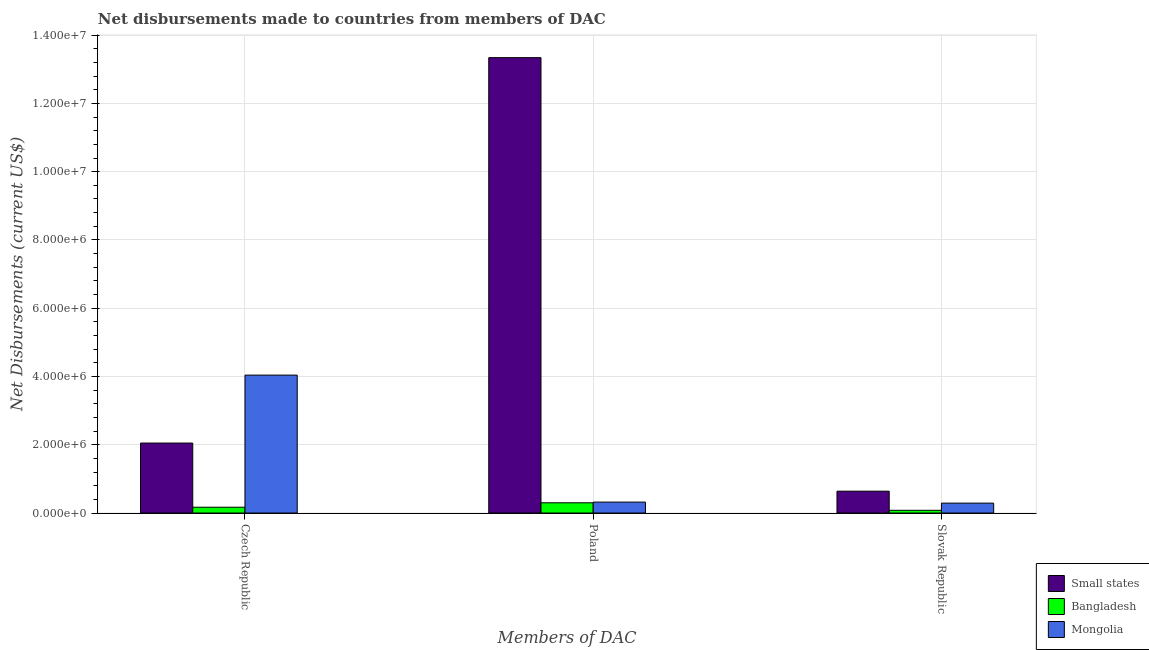How many different coloured bars are there?
Keep it short and to the point. 3. Are the number of bars on each tick of the X-axis equal?
Make the answer very short. Yes. How many bars are there on the 3rd tick from the left?
Your answer should be compact. 3. How many bars are there on the 1st tick from the right?
Provide a succinct answer. 3. What is the label of the 3rd group of bars from the left?
Provide a short and direct response. Slovak Republic. What is the net disbursements made by czech republic in Mongolia?
Make the answer very short. 4.04e+06. Across all countries, what is the maximum net disbursements made by poland?
Make the answer very short. 1.33e+07. Across all countries, what is the minimum net disbursements made by slovak republic?
Make the answer very short. 8.00e+04. In which country was the net disbursements made by slovak republic maximum?
Make the answer very short. Small states. In which country was the net disbursements made by poland minimum?
Ensure brevity in your answer.  Bangladesh. What is the total net disbursements made by slovak republic in the graph?
Your response must be concise. 1.01e+06. What is the difference between the net disbursements made by slovak republic in Bangladesh and that in Mongolia?
Ensure brevity in your answer.  -2.10e+05. What is the difference between the net disbursements made by slovak republic in Bangladesh and the net disbursements made by czech republic in Mongolia?
Make the answer very short. -3.96e+06. What is the average net disbursements made by slovak republic per country?
Your response must be concise. 3.37e+05. What is the difference between the net disbursements made by poland and net disbursements made by slovak republic in Bangladesh?
Make the answer very short. 2.20e+05. In how many countries, is the net disbursements made by slovak republic greater than 3200000 US$?
Keep it short and to the point. 0. What is the ratio of the net disbursements made by czech republic in Small states to that in Mongolia?
Provide a short and direct response. 0.51. Is the net disbursements made by czech republic in Small states less than that in Mongolia?
Offer a terse response. Yes. What is the difference between the highest and the second highest net disbursements made by czech republic?
Your answer should be compact. 1.99e+06. What is the difference between the highest and the lowest net disbursements made by czech republic?
Keep it short and to the point. 3.87e+06. In how many countries, is the net disbursements made by czech republic greater than the average net disbursements made by czech republic taken over all countries?
Ensure brevity in your answer.  1. What does the 3rd bar from the left in Czech Republic represents?
Offer a very short reply. Mongolia. What does the 1st bar from the right in Czech Republic represents?
Your response must be concise. Mongolia. How many bars are there?
Provide a short and direct response. 9. How many countries are there in the graph?
Give a very brief answer. 3. What is the difference between two consecutive major ticks on the Y-axis?
Your answer should be compact. 2.00e+06. Where does the legend appear in the graph?
Provide a succinct answer. Bottom right. How are the legend labels stacked?
Give a very brief answer. Vertical. What is the title of the graph?
Offer a terse response. Net disbursements made to countries from members of DAC. Does "United Kingdom" appear as one of the legend labels in the graph?
Provide a short and direct response. No. What is the label or title of the X-axis?
Your response must be concise. Members of DAC. What is the label or title of the Y-axis?
Give a very brief answer. Net Disbursements (current US$). What is the Net Disbursements (current US$) of Small states in Czech Republic?
Ensure brevity in your answer.  2.05e+06. What is the Net Disbursements (current US$) of Mongolia in Czech Republic?
Ensure brevity in your answer.  4.04e+06. What is the Net Disbursements (current US$) of Small states in Poland?
Your answer should be very brief. 1.33e+07. What is the Net Disbursements (current US$) of Bangladesh in Poland?
Make the answer very short. 3.00e+05. What is the Net Disbursements (current US$) of Small states in Slovak Republic?
Offer a terse response. 6.40e+05. Across all Members of DAC, what is the maximum Net Disbursements (current US$) in Small states?
Offer a terse response. 1.33e+07. Across all Members of DAC, what is the maximum Net Disbursements (current US$) of Bangladesh?
Provide a succinct answer. 3.00e+05. Across all Members of DAC, what is the maximum Net Disbursements (current US$) of Mongolia?
Keep it short and to the point. 4.04e+06. Across all Members of DAC, what is the minimum Net Disbursements (current US$) of Small states?
Provide a short and direct response. 6.40e+05. Across all Members of DAC, what is the minimum Net Disbursements (current US$) of Bangladesh?
Give a very brief answer. 8.00e+04. What is the total Net Disbursements (current US$) in Small states in the graph?
Offer a very short reply. 1.60e+07. What is the total Net Disbursements (current US$) in Bangladesh in the graph?
Ensure brevity in your answer.  5.50e+05. What is the total Net Disbursements (current US$) of Mongolia in the graph?
Your answer should be very brief. 4.65e+06. What is the difference between the Net Disbursements (current US$) in Small states in Czech Republic and that in Poland?
Give a very brief answer. -1.13e+07. What is the difference between the Net Disbursements (current US$) of Mongolia in Czech Republic and that in Poland?
Ensure brevity in your answer.  3.72e+06. What is the difference between the Net Disbursements (current US$) of Small states in Czech Republic and that in Slovak Republic?
Give a very brief answer. 1.41e+06. What is the difference between the Net Disbursements (current US$) of Bangladesh in Czech Republic and that in Slovak Republic?
Your response must be concise. 9.00e+04. What is the difference between the Net Disbursements (current US$) of Mongolia in Czech Republic and that in Slovak Republic?
Offer a terse response. 3.75e+06. What is the difference between the Net Disbursements (current US$) in Small states in Poland and that in Slovak Republic?
Ensure brevity in your answer.  1.27e+07. What is the difference between the Net Disbursements (current US$) of Bangladesh in Poland and that in Slovak Republic?
Your answer should be very brief. 2.20e+05. What is the difference between the Net Disbursements (current US$) in Mongolia in Poland and that in Slovak Republic?
Make the answer very short. 3.00e+04. What is the difference between the Net Disbursements (current US$) of Small states in Czech Republic and the Net Disbursements (current US$) of Bangladesh in Poland?
Provide a short and direct response. 1.75e+06. What is the difference between the Net Disbursements (current US$) in Small states in Czech Republic and the Net Disbursements (current US$) in Mongolia in Poland?
Your response must be concise. 1.73e+06. What is the difference between the Net Disbursements (current US$) of Small states in Czech Republic and the Net Disbursements (current US$) of Bangladesh in Slovak Republic?
Offer a very short reply. 1.97e+06. What is the difference between the Net Disbursements (current US$) of Small states in Czech Republic and the Net Disbursements (current US$) of Mongolia in Slovak Republic?
Provide a succinct answer. 1.76e+06. What is the difference between the Net Disbursements (current US$) of Small states in Poland and the Net Disbursements (current US$) of Bangladesh in Slovak Republic?
Offer a very short reply. 1.33e+07. What is the difference between the Net Disbursements (current US$) in Small states in Poland and the Net Disbursements (current US$) in Mongolia in Slovak Republic?
Your response must be concise. 1.30e+07. What is the difference between the Net Disbursements (current US$) of Bangladesh in Poland and the Net Disbursements (current US$) of Mongolia in Slovak Republic?
Give a very brief answer. 10000. What is the average Net Disbursements (current US$) of Small states per Members of DAC?
Your answer should be very brief. 5.34e+06. What is the average Net Disbursements (current US$) in Bangladesh per Members of DAC?
Your answer should be compact. 1.83e+05. What is the average Net Disbursements (current US$) of Mongolia per Members of DAC?
Provide a succinct answer. 1.55e+06. What is the difference between the Net Disbursements (current US$) in Small states and Net Disbursements (current US$) in Bangladesh in Czech Republic?
Your answer should be compact. 1.88e+06. What is the difference between the Net Disbursements (current US$) of Small states and Net Disbursements (current US$) of Mongolia in Czech Republic?
Offer a terse response. -1.99e+06. What is the difference between the Net Disbursements (current US$) in Bangladesh and Net Disbursements (current US$) in Mongolia in Czech Republic?
Your response must be concise. -3.87e+06. What is the difference between the Net Disbursements (current US$) in Small states and Net Disbursements (current US$) in Bangladesh in Poland?
Offer a terse response. 1.30e+07. What is the difference between the Net Disbursements (current US$) in Small states and Net Disbursements (current US$) in Mongolia in Poland?
Offer a very short reply. 1.30e+07. What is the difference between the Net Disbursements (current US$) of Bangladesh and Net Disbursements (current US$) of Mongolia in Poland?
Offer a terse response. -2.00e+04. What is the difference between the Net Disbursements (current US$) in Small states and Net Disbursements (current US$) in Bangladesh in Slovak Republic?
Ensure brevity in your answer.  5.60e+05. What is the difference between the Net Disbursements (current US$) of Bangladesh and Net Disbursements (current US$) of Mongolia in Slovak Republic?
Give a very brief answer. -2.10e+05. What is the ratio of the Net Disbursements (current US$) of Small states in Czech Republic to that in Poland?
Give a very brief answer. 0.15. What is the ratio of the Net Disbursements (current US$) of Bangladesh in Czech Republic to that in Poland?
Keep it short and to the point. 0.57. What is the ratio of the Net Disbursements (current US$) of Mongolia in Czech Republic to that in Poland?
Provide a succinct answer. 12.62. What is the ratio of the Net Disbursements (current US$) in Small states in Czech Republic to that in Slovak Republic?
Give a very brief answer. 3.2. What is the ratio of the Net Disbursements (current US$) of Bangladesh in Czech Republic to that in Slovak Republic?
Keep it short and to the point. 2.12. What is the ratio of the Net Disbursements (current US$) of Mongolia in Czech Republic to that in Slovak Republic?
Give a very brief answer. 13.93. What is the ratio of the Net Disbursements (current US$) of Small states in Poland to that in Slovak Republic?
Provide a succinct answer. 20.84. What is the ratio of the Net Disbursements (current US$) in Bangladesh in Poland to that in Slovak Republic?
Give a very brief answer. 3.75. What is the ratio of the Net Disbursements (current US$) of Mongolia in Poland to that in Slovak Republic?
Your answer should be very brief. 1.1. What is the difference between the highest and the second highest Net Disbursements (current US$) of Small states?
Your response must be concise. 1.13e+07. What is the difference between the highest and the second highest Net Disbursements (current US$) in Bangladesh?
Your response must be concise. 1.30e+05. What is the difference between the highest and the second highest Net Disbursements (current US$) of Mongolia?
Provide a short and direct response. 3.72e+06. What is the difference between the highest and the lowest Net Disbursements (current US$) of Small states?
Your answer should be very brief. 1.27e+07. What is the difference between the highest and the lowest Net Disbursements (current US$) in Bangladesh?
Your answer should be compact. 2.20e+05. What is the difference between the highest and the lowest Net Disbursements (current US$) in Mongolia?
Offer a terse response. 3.75e+06. 